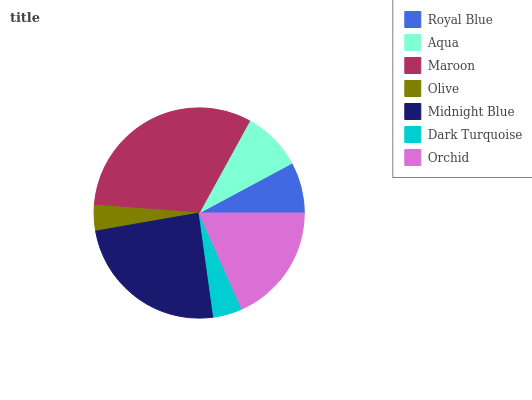Is Olive the minimum?
Answer yes or no. Yes. Is Maroon the maximum?
Answer yes or no. Yes. Is Aqua the minimum?
Answer yes or no. No. Is Aqua the maximum?
Answer yes or no. No. Is Aqua greater than Royal Blue?
Answer yes or no. Yes. Is Royal Blue less than Aqua?
Answer yes or no. Yes. Is Royal Blue greater than Aqua?
Answer yes or no. No. Is Aqua less than Royal Blue?
Answer yes or no. No. Is Aqua the high median?
Answer yes or no. Yes. Is Aqua the low median?
Answer yes or no. Yes. Is Dark Turquoise the high median?
Answer yes or no. No. Is Dark Turquoise the low median?
Answer yes or no. No. 